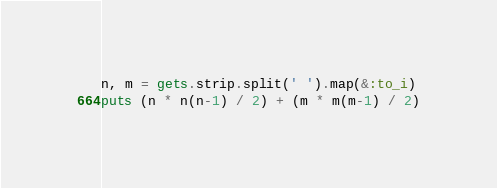Convert code to text. <code><loc_0><loc_0><loc_500><loc_500><_Ruby_>n, m = gets.strip.split(' ').map(&:to_i)
puts (n * n(n-1) / 2) + (m * m(m-1) / 2)</code> 